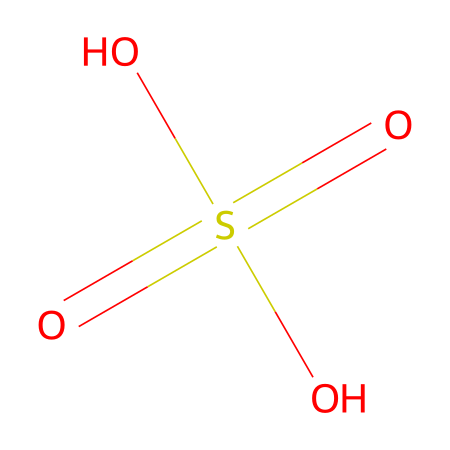How many oxygen atoms are present in sulfuric acid? From the SMILES representation O=S(=O)(O)O, we can count the oxygen atoms. There are four oxygen atoms represented by four 'O' symbols.
Answer: four What is the oxidation state of sulfur in sulfuric acid? The sulfur atom in the chemical is bonded to four oxygen atoms and has a double bond with two of them. The formal charge calculation shows that sulfur has an oxidation state of +6 in this structure.
Answer: +6 What type of bonds are present between sulfur and oxygen in sulfuric acid? In the structure, sulfur (S) forms two double bonds with two of the oxygen atoms and two single bonds with the other two oxygen atoms, indicating both double and single bonds.
Answer: double and single What is the molecular formula of sulfuric acid? The SMILES notation indicates one sulfur atom (S), four oxygen atoms (O), and two hydrogen atoms (H), thus the molecular formula can be derived as H2SO4.
Answer: H2SO4 What functional group is characteristic of sulfuric acid? Sulfuric acid has a sulfate functional group, which is indicated by the presence of sulfur bonded to oxygen atoms and the -OH groups in the structure.
Answer: sulfate How many total atoms are in sulfuric acid? Considering the composition from the SMILES representation, there is one sulfur atom, four oxygen atoms, and two hydrogen atoms, leading to a total of seven atoms in sulfuric acid.
Answer: seven What property is affected by the presence of sulfur in acid rain? The presence of sulfur in sulfuric acid contributes to its acidity and corrosive properties, which are significant factors regarding the environmental impact of acid rain.
Answer: acidity 